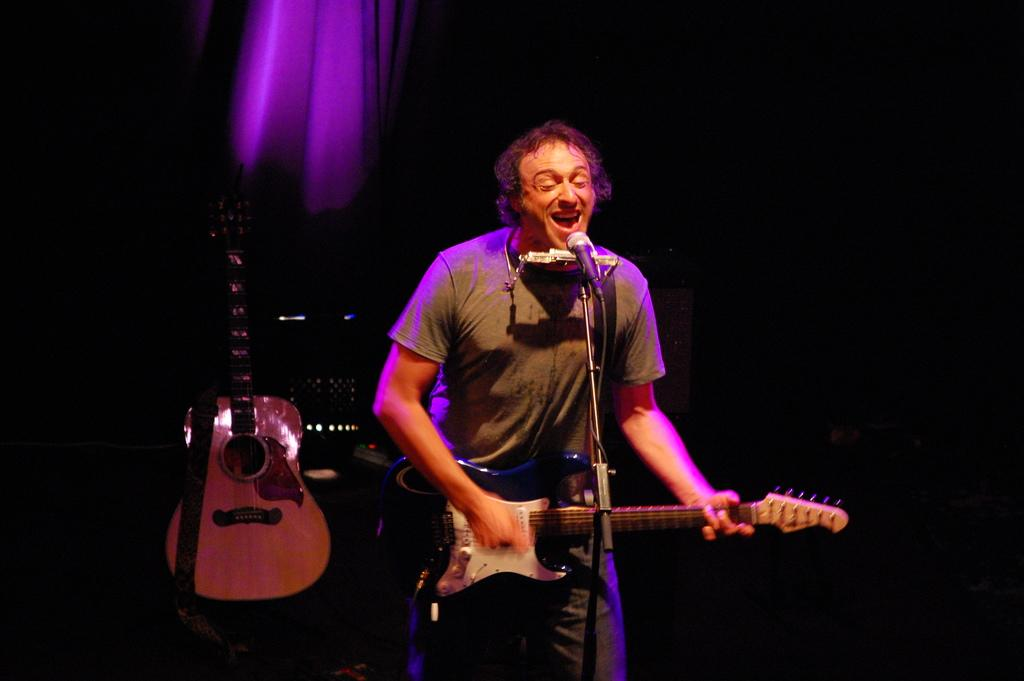What is the man in the image doing? The man is playing a guitar and singing a song. What object is in front of the man? There is a microphone in front of the man. Can you describe the other musical instrument visible in the image? There is another guitar visible behind the man. What type of sofa can be seen in the background of the image? There is no sofa present in the image. Can you tell me which downtown area the man is performing in? The image does not provide any information about the location or downtown area. 